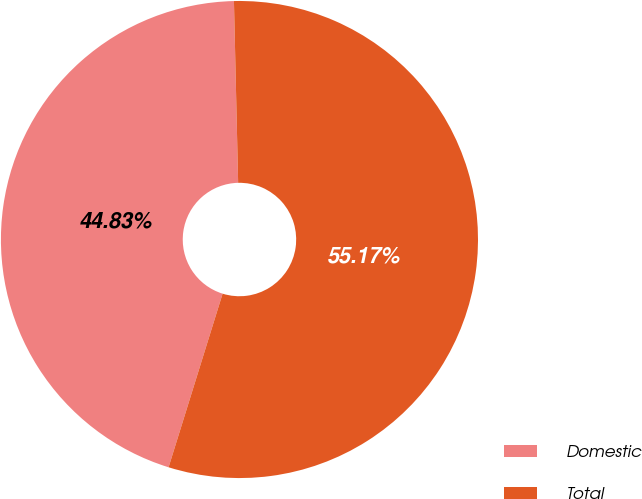Convert chart. <chart><loc_0><loc_0><loc_500><loc_500><pie_chart><fcel>Domestic<fcel>Total<nl><fcel>44.83%<fcel>55.17%<nl></chart> 